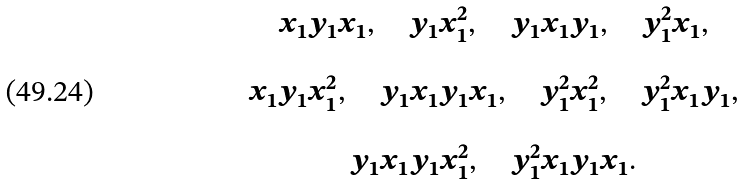<formula> <loc_0><loc_0><loc_500><loc_500>\begin{array} { c } x _ { 1 } y _ { 1 } x _ { 1 } , \quad y _ { 1 } x _ { 1 } ^ { 2 } , \quad y _ { 1 } x _ { 1 } y _ { 1 } , \quad y _ { 1 } ^ { 2 } x _ { 1 } , \\ \\ x _ { 1 } y _ { 1 } x _ { 1 } ^ { 2 } , \quad y _ { 1 } x _ { 1 } y _ { 1 } x _ { 1 } , \quad y _ { 1 } ^ { 2 } x _ { 1 } ^ { 2 } , \quad y _ { 1 } ^ { 2 } x _ { 1 } y _ { 1 } , \\ \\ y _ { 1 } x _ { 1 } y _ { 1 } x _ { 1 } ^ { 2 } , \quad y _ { 1 } ^ { 2 } x _ { 1 } y _ { 1 } x _ { 1 } . \\ \end{array}</formula> 